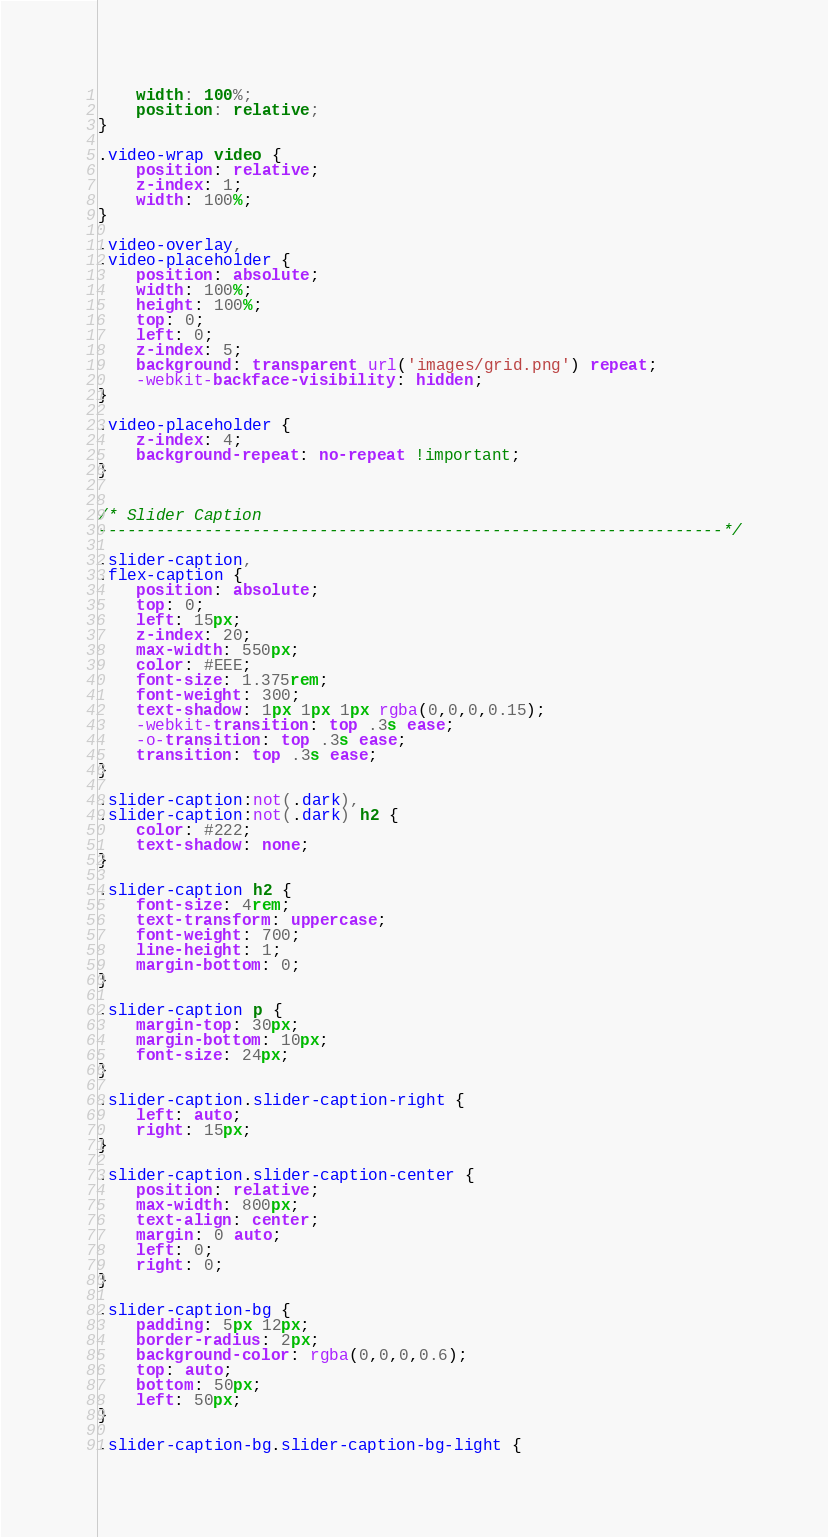<code> <loc_0><loc_0><loc_500><loc_500><_CSS_>	width: 100%;
	position: relative;
}

.video-wrap video {
	position: relative;
	z-index: 1;
	width: 100%;
}

.video-overlay,
.video-placeholder {
	position: absolute;
	width: 100%;
	height: 100%;
	top: 0;
	left: 0;
	z-index: 5;
	background: transparent url('images/grid.png') repeat;
	-webkit-backface-visibility: hidden;
}

.video-placeholder {
	z-index: 4;
	background-repeat: no-repeat !important;
}


/* Slider Caption
-----------------------------------------------------------------*/

.slider-caption,
.flex-caption {
	position: absolute;
	top: 0;
	left: 15px;
	z-index: 20;
	max-width: 550px;
	color: #EEE;
	font-size: 1.375rem;
	font-weight: 300;
	text-shadow: 1px 1px 1px rgba(0,0,0,0.15);
	-webkit-transition: top .3s ease;
	-o-transition: top .3s ease;
	transition: top .3s ease;
}

.slider-caption:not(.dark),
.slider-caption:not(.dark) h2 {
	color: #222;
	text-shadow: none;
}

.slider-caption h2 {
	font-size: 4rem;
	text-transform: uppercase;
	font-weight: 700;
	line-height: 1;
	margin-bottom: 0;
}

.slider-caption p {
	margin-top: 30px;
	margin-bottom: 10px;
	font-size: 24px;
}

.slider-caption.slider-caption-right {
	left: auto;
	right: 15px;
}

.slider-caption.slider-caption-center {
	position: relative;
	max-width: 800px;
	text-align: center;
	margin: 0 auto;
	left: 0;
	right: 0;
}

.slider-caption-bg {
	padding: 5px 12px;
	border-radius: 2px;
	background-color: rgba(0,0,0,0.6);
	top: auto;
	bottom: 50px;
	left: 50px;
}

.slider-caption-bg.slider-caption-bg-light {</code> 